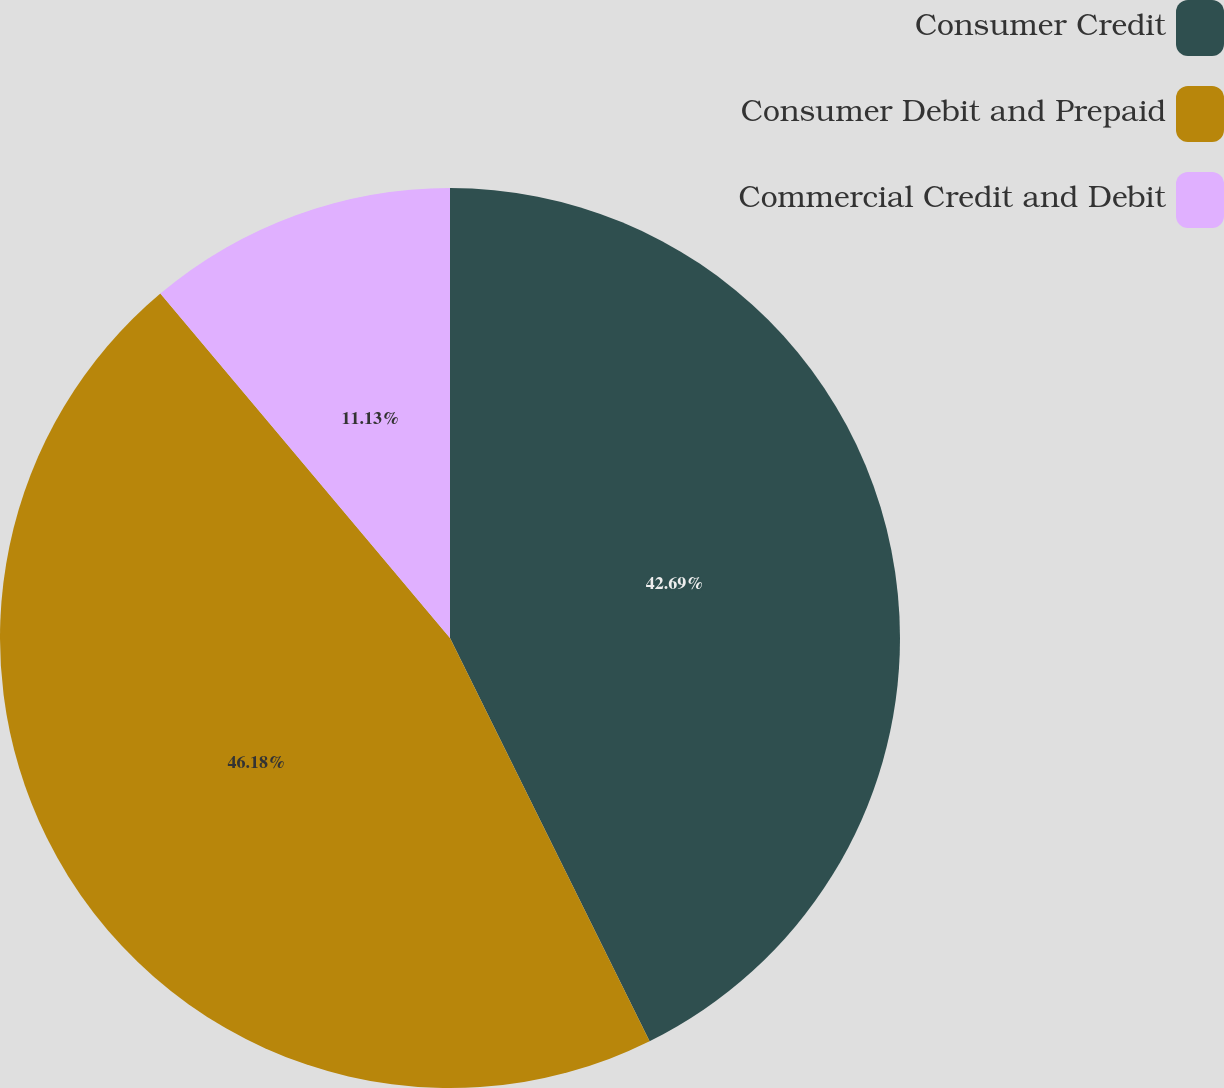Convert chart. <chart><loc_0><loc_0><loc_500><loc_500><pie_chart><fcel>Consumer Credit<fcel>Consumer Debit and Prepaid<fcel>Commercial Credit and Debit<nl><fcel>42.69%<fcel>46.19%<fcel>11.13%<nl></chart> 